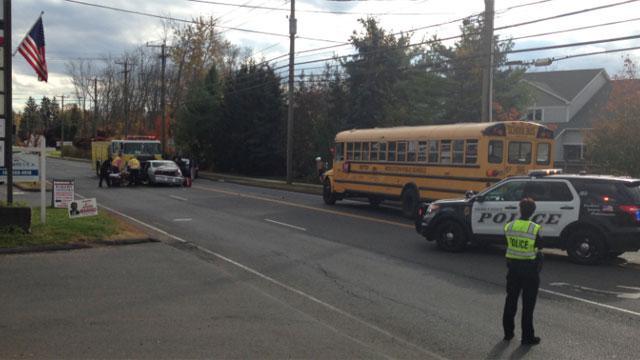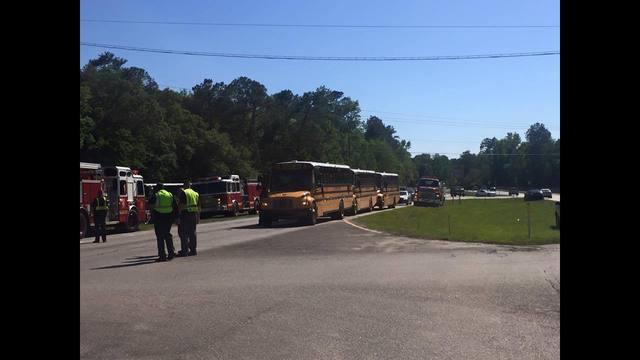The first image is the image on the left, the second image is the image on the right. Evaluate the accuracy of this statement regarding the images: "In at least one image there is one parked yellow bus near one police  vehicle.". Is it true? Answer yes or no. Yes. The first image is the image on the left, the second image is the image on the right. Analyze the images presented: Is the assertion "Exactly one image contains both school buses and fire trucks." valid? Answer yes or no. No. 